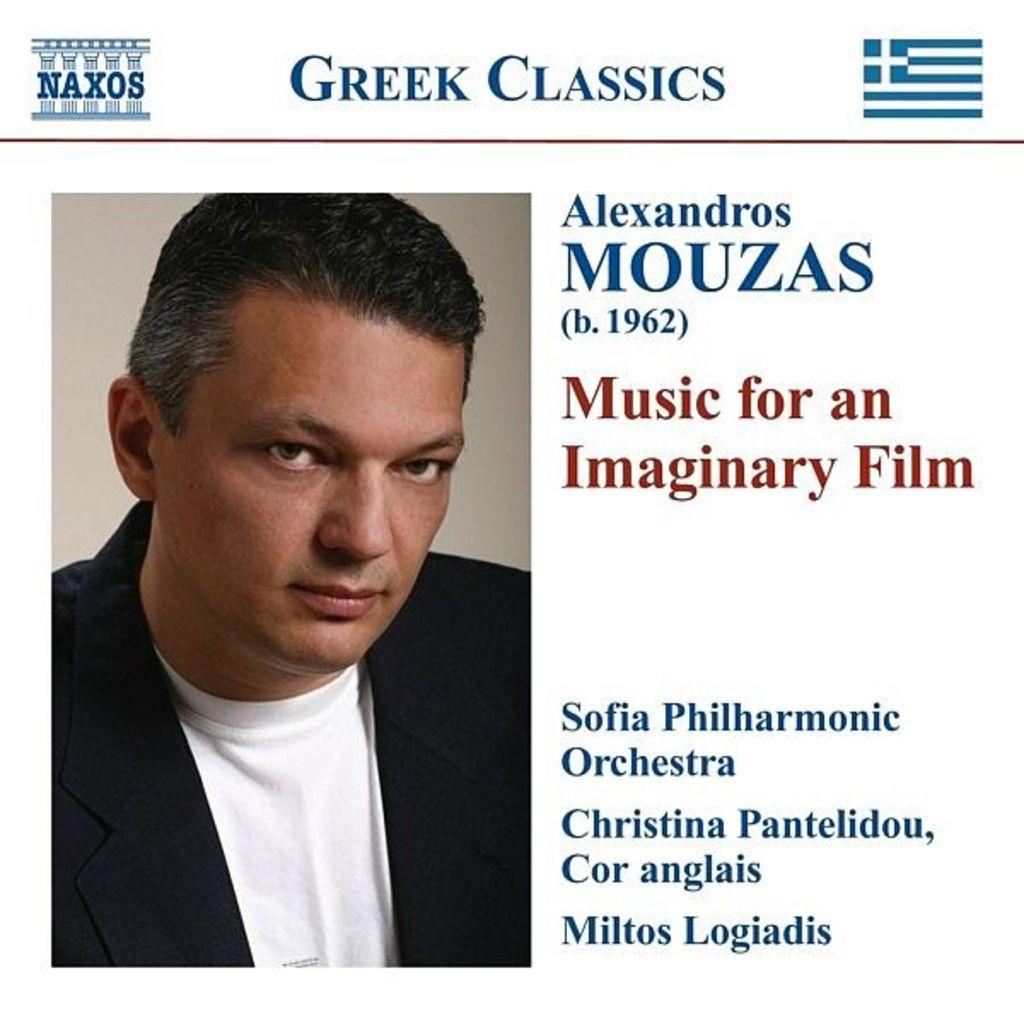What is the main subject of the image? There is a person in the image. Can you describe the person's attire? The person is wearing a black suit. Is there any text associated with the image? Yes, there is text written beside and above the image. What type of berry is being picked by the person in the image? There is no berry or person picking berries present in the image. 